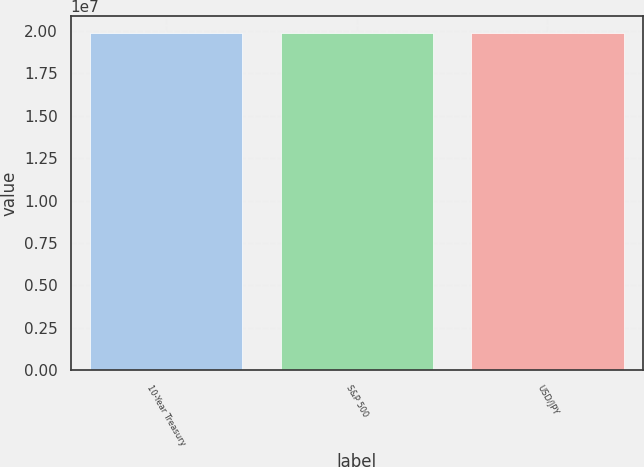<chart> <loc_0><loc_0><loc_500><loc_500><bar_chart><fcel>10-Year Treasury<fcel>S&P 500<fcel>USD/JPY<nl><fcel>1.9902e+07<fcel>1.9902e+07<fcel>1.9902e+07<nl></chart> 